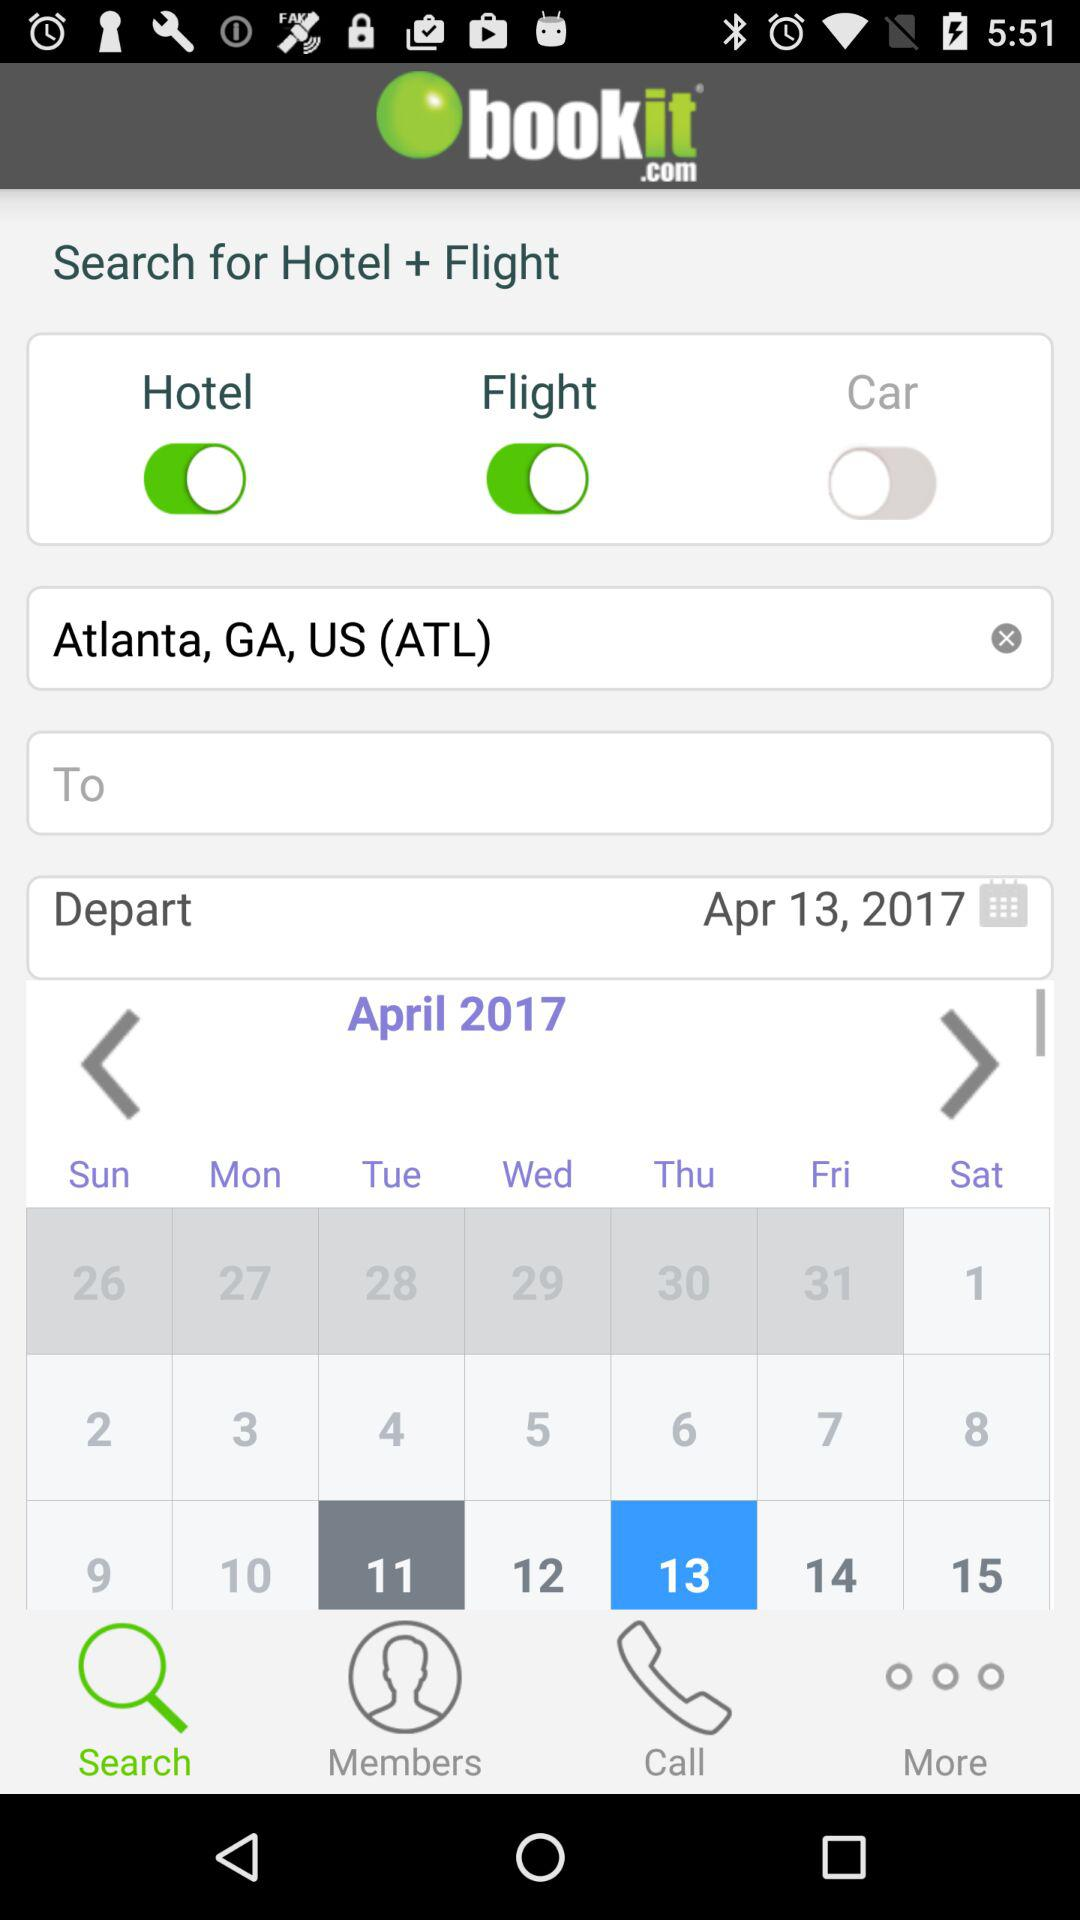What's the departure place? The departure place is Atlanta, GA, US (ATL). 